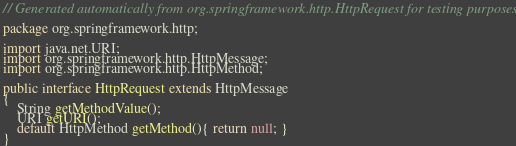<code> <loc_0><loc_0><loc_500><loc_500><_Java_>// Generated automatically from org.springframework.http.HttpRequest for testing purposes

package org.springframework.http;

import java.net.URI;
import org.springframework.http.HttpMessage;
import org.springframework.http.HttpMethod;

public interface HttpRequest extends HttpMessage
{
    String getMethodValue();
    URI getURI();
    default HttpMethod getMethod(){ return null; }
}
</code> 